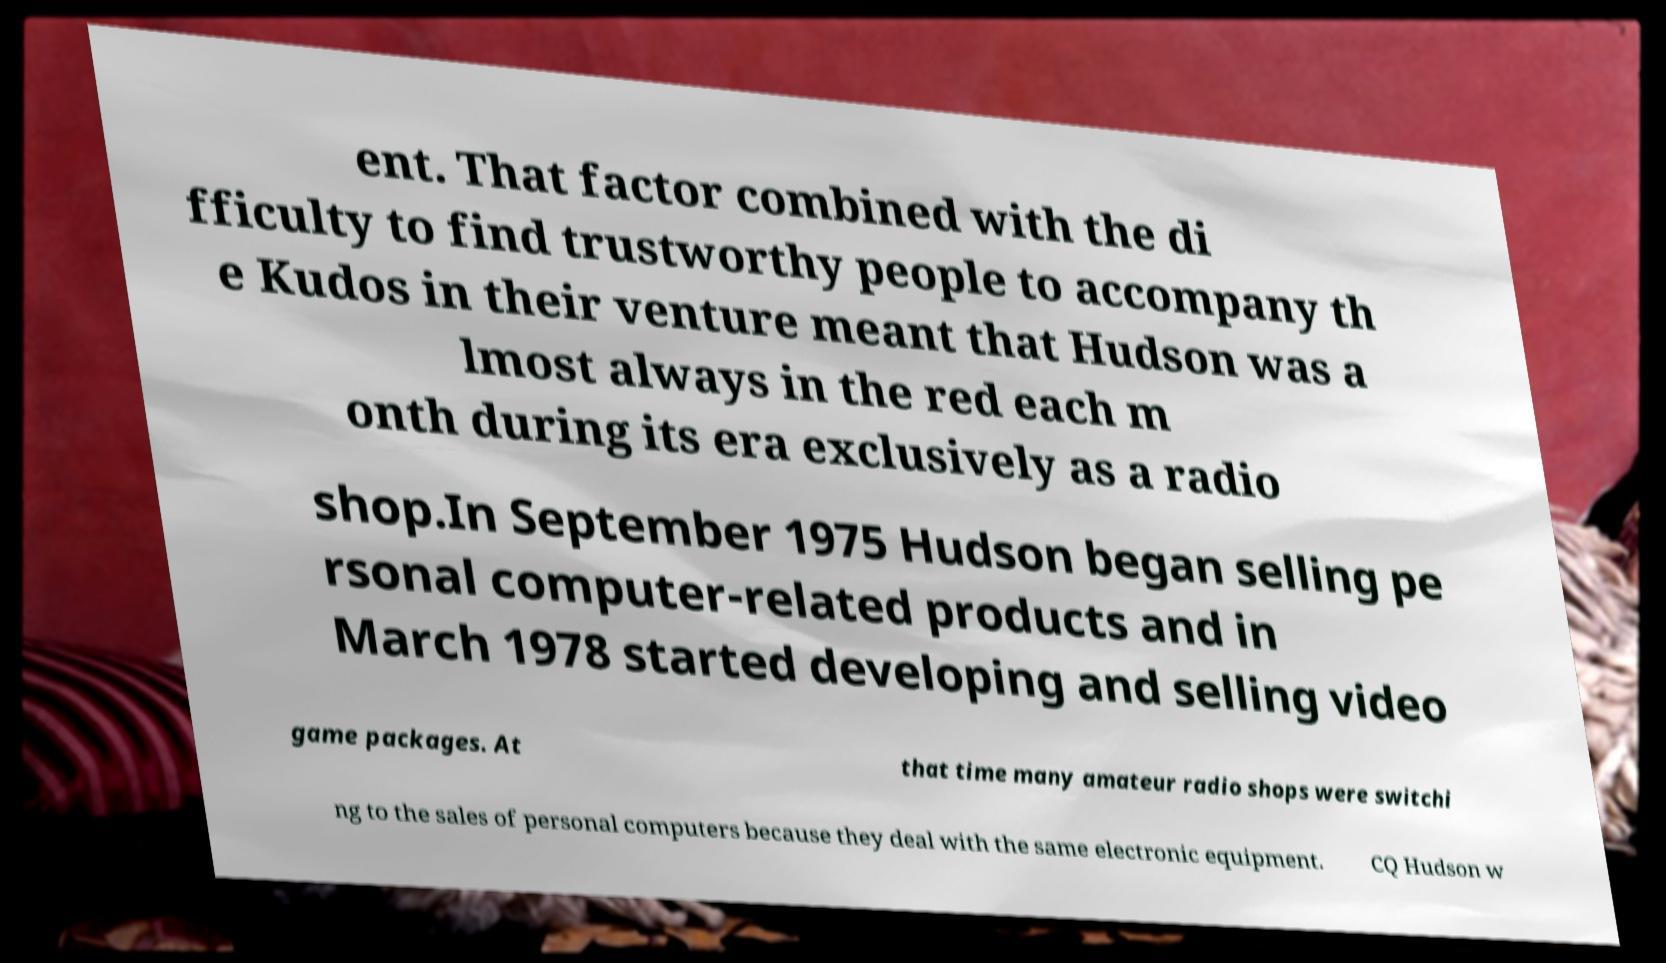For documentation purposes, I need the text within this image transcribed. Could you provide that? ent. That factor combined with the di fficulty to find trustworthy people to accompany th e Kudos in their venture meant that Hudson was a lmost always in the red each m onth during its era exclusively as a radio shop.In September 1975 Hudson began selling pe rsonal computer-related products and in March 1978 started developing and selling video game packages. At that time many amateur radio shops were switchi ng to the sales of personal computers because they deal with the same electronic equipment. CQ Hudson w 